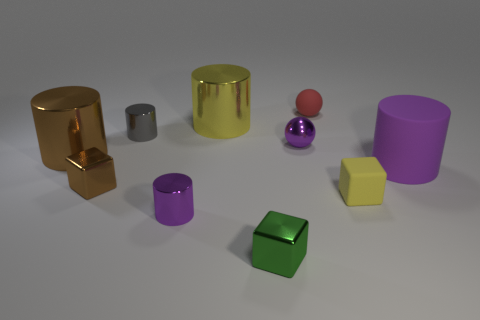How many things are either small green cubes or large purple shiny spheres?
Your answer should be compact. 1. Do the big object that is in front of the big brown metallic cylinder and the small purple cylinder have the same material?
Your answer should be compact. No. How many objects are objects to the left of the small red rubber sphere or brown cylinders?
Ensure brevity in your answer.  7. What color is the tiny cube that is the same material as the green thing?
Give a very brief answer. Brown. Are there any metal blocks that have the same size as the gray metal cylinder?
Offer a terse response. Yes. There is a big cylinder that is to the right of the green cube; does it have the same color as the tiny metal sphere?
Provide a short and direct response. Yes. There is a thing that is both right of the big yellow thing and behind the small gray metal cylinder; what is its color?
Give a very brief answer. Red. There is a brown shiny thing that is the same size as the purple sphere; what shape is it?
Keep it short and to the point. Cube. Is there another yellow object of the same shape as the big matte thing?
Make the answer very short. Yes. There is a cylinder that is right of the purple sphere; does it have the same size as the yellow cylinder?
Keep it short and to the point. Yes. 